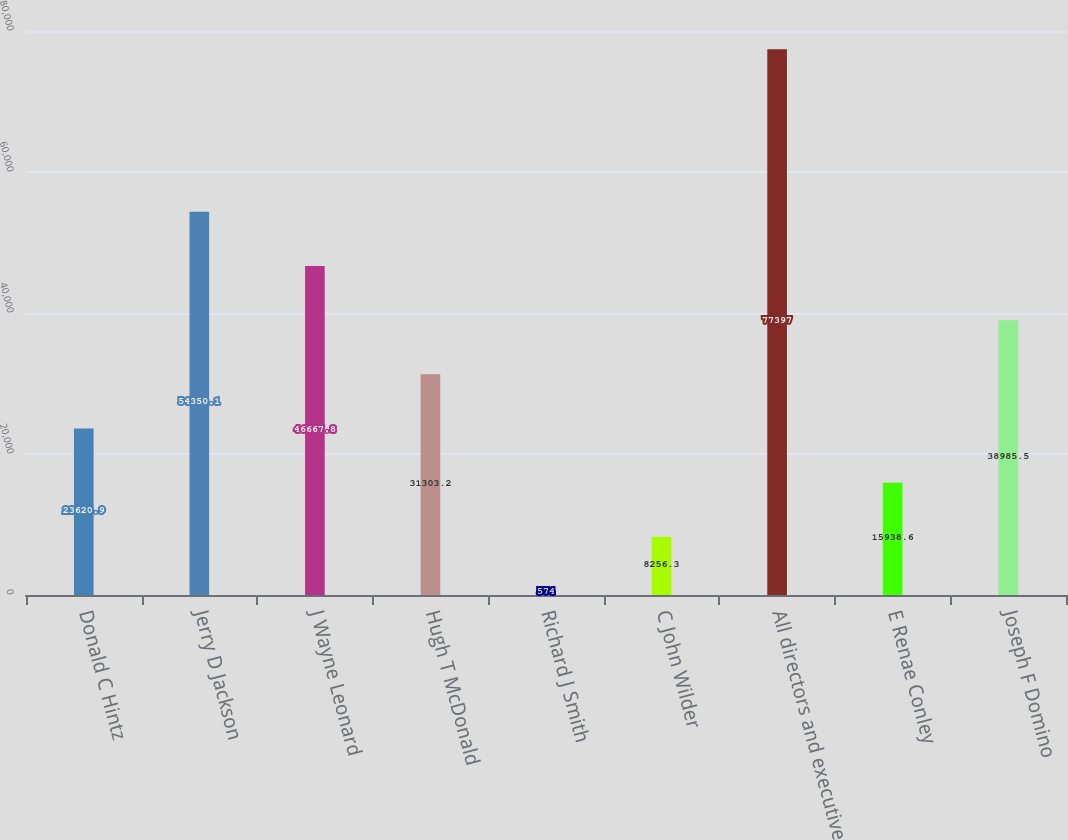Convert chart to OTSL. <chart><loc_0><loc_0><loc_500><loc_500><bar_chart><fcel>Donald C Hintz<fcel>Jerry D Jackson<fcel>J Wayne Leonard<fcel>Hugh T McDonald<fcel>Richard J Smith<fcel>C John Wilder<fcel>All directors and executive<fcel>E Renae Conley<fcel>Joseph F Domino<nl><fcel>23620.9<fcel>54350.1<fcel>46667.8<fcel>31303.2<fcel>574<fcel>8256.3<fcel>77397<fcel>15938.6<fcel>38985.5<nl></chart> 